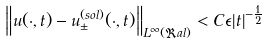Convert formula to latex. <formula><loc_0><loc_0><loc_500><loc_500>\left \| u ( \cdot , t ) - u ^ { ( s o l ) } _ { \pm } ( \cdot , t ) \right \| _ { L ^ { \infty } ( \Re a l ) } < C \epsilon | t | ^ { - \frac { 1 } { 2 } }</formula> 